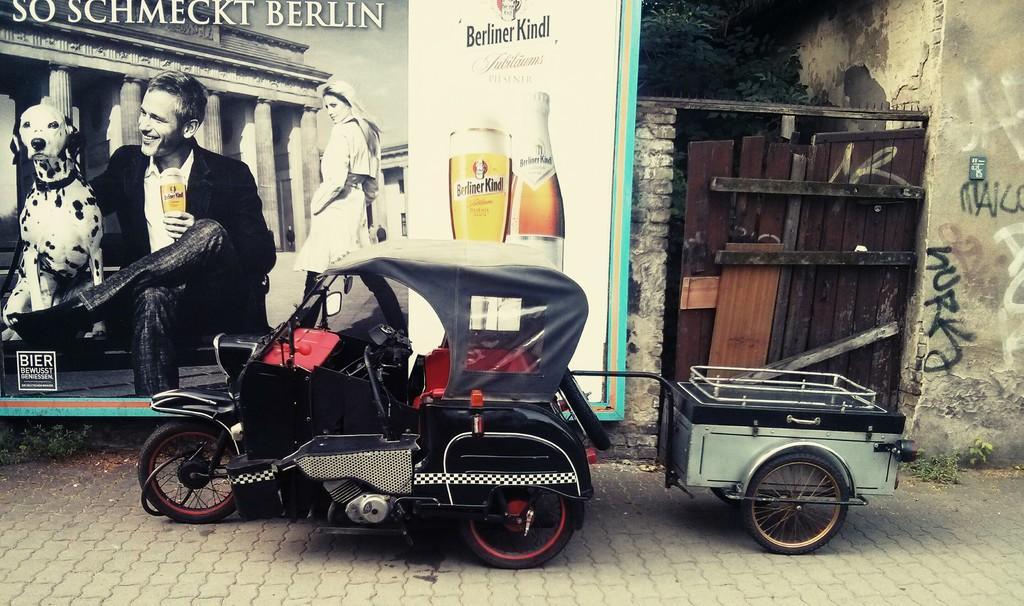How would you summarize this image in a sentence or two? In this image there is a vehicle parked on a path, behind that there is a banner with some images and text, beside that there is a wooden gate of a building. 